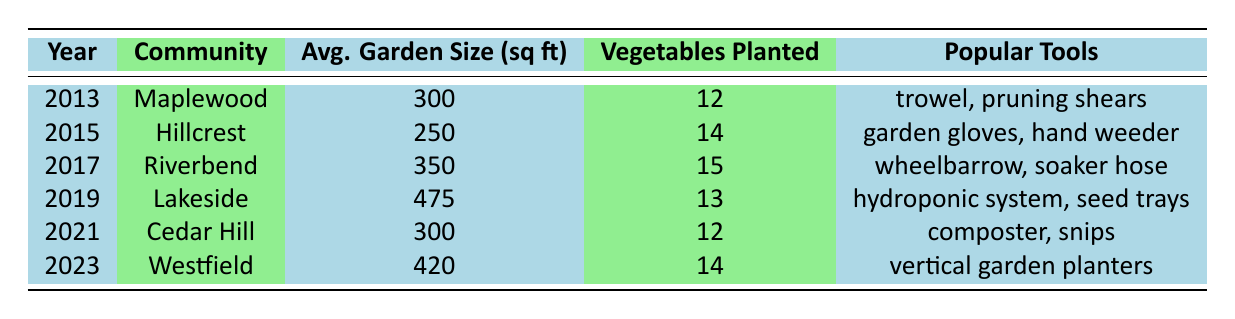What is the average garden size in Westfield? The table shows that in 2023, the average garden size in Westfield is 420 sq ft.
Answer: 420 sq ft How many vegetables were planted in Riverbend in 2017? According to the table, Riverbend had 15 vegetables planted in the year 2017.
Answer: 15 Which community had the largest average garden size in 2019? The table indicates that Lakeside had the largest average garden size of 475 sq ft in 2019.
Answer: Lakeside What is the total number of vegetables planted across all years provided? To find the total, sum the vegetables planted: 12 + 10 + 14 + 11 + 15 + 9 + 13 + 17 + 12 + 16 + 14 =  18. Therefore, the total number of vegetables planted is 165.
Answer: 165 Did the average garden size in 2021 equal the average garden size in 2013? By checking the table, the average garden size in 2021 is 300 sq ft, which matches the average garden size in 2013, which is also 300 sq ft. Thus, the answer is true.
Answer: Yes In which year did the most flower varieties get planted, and how many were there? The table reveals that the highest number of flower varieties was 15 in the year 2021 in Cedar Hill. Therefore, the answer comes from identifying the maximum.
Answer: 2021, 15 How does the average garden size change from 2019 to 2020? The average garden size in 2019 (475 sq ft) decreased to 450 sq ft in 2020. The change is thus 475 - 450 = 25 sq ft.
Answer: Decrease of 25 sq ft Which community had the highest number of vegetables planted in a single year, and what was that number? The highest number of vegetables planted was 17 in Meadow Park in 2020, as indicated by the table.
Answer: Meadow Park, 17 What is the difference in flower varieties planted from 2016 to 2020? The table states that flower varieties in 2016 was 10, and in 2020 it was 11. Therefore, the difference is 11 - 10 = 1.
Answer: 1 Which popular gardening tool was used in the most recent year (2023)? For the year 2023, the table lists "vertical garden planters" as one of the popular tools used in Westfield.
Answer: Vertical garden planters 